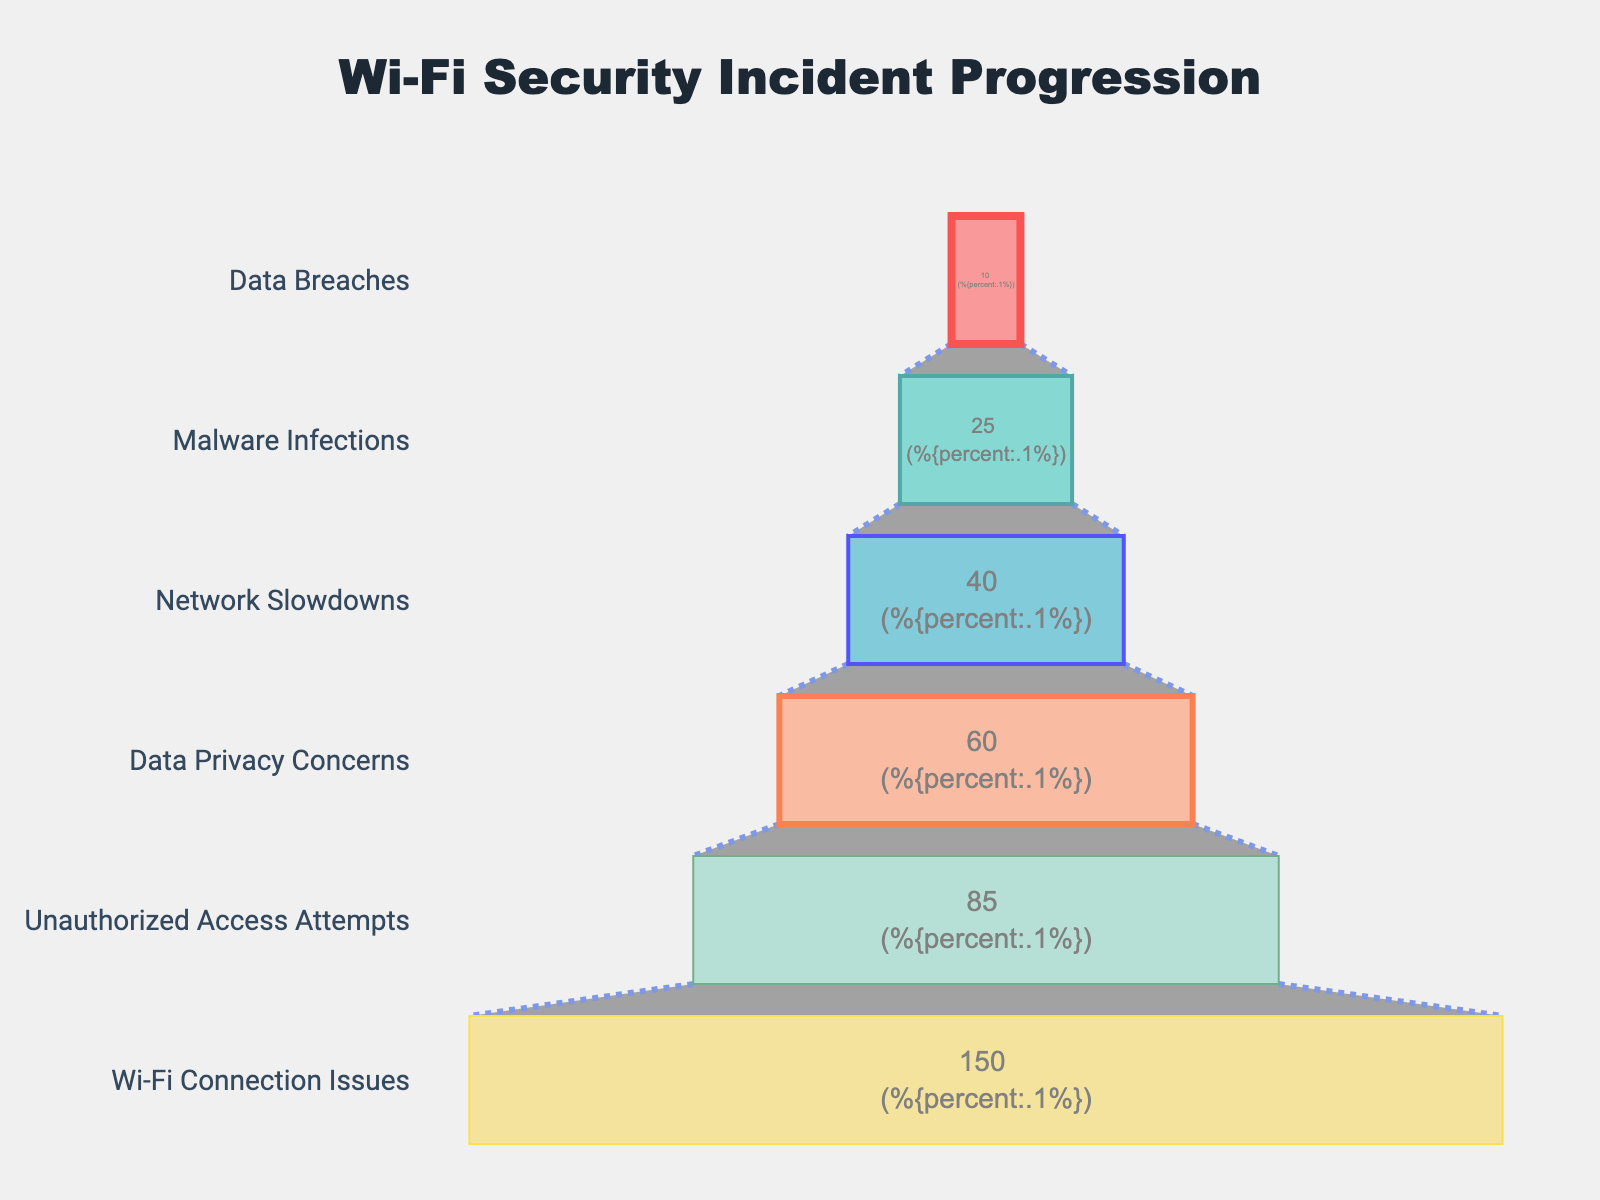What is the title of the Funnel Chart? The title of the Funnel Chart is located at the top of the figure and reads "Wi-Fi Security Incident Progression."
Answer: Wi-Fi Security Incident Progression How many stages are represented in the Funnel Chart? Each row in the chart represents a stage, so we count the number of rows to find the total number of stages. There are six stages in the chart.
Answer: six Which stage has the highest number of incidents? The stage with the highest number of incidents is the first one listed in the chart, which is "Wi-Fi Connection Issues" with 150 incidents.
Answer: Wi-Fi Connection Issues How many incidents are attributed to Malware Infections? We look for the stage labeled "Malware Infections" and see that it has 25 incidents.
Answer: 25 What percentage of initial incidents are Data Privacy Concerns? Initially, there are 150 incidents of Wi-Fi Connection Issues. Data Privacy Concerns have 60 incidents. The percentage is (60 / 150) * 100.
Answer: 40% How many more incidents are there for Wi-Fi Connection Issues compared to Network Slowdowns? Wi-Fi Connection Issues have 150 incidents, and Network Slowdowns have 40 incidents. The difference is 150 - 40.
Answer: 110 What is the combined number of incidents for Unauthorized Access Attempts and Data Breaches? Unauthorized Access Attempts have 85 incidents, and Data Breaches have 10 incidents. Their combined total is 85 + 10.
Answer: 95 Which stages have fewer incidents than Data Privacy Concerns? Data Privacy Concerns have 60 incidents. The stages "Network Slowdowns" (40 incidents), "Malware Infections" (25 incidents), and "Data Breaches" (10 incidents) all have fewer incidents.
Answer: Network Slowdowns, Malware Infections, Data Breaches What is the average number of incidents across all stages? Sum all the incidents (150 + 85 + 60 + 40 + 25 + 10) to get 370. Divide by the number of stages, which is 6. The average is 370 / 6.
Answer: approximately 61.67 What trend can be observed in the number of incidents as we move from minor to severe stages in the funnel? As we move from minor to severe stages, the number of incidents decreases. This trend demonstrates a reduction in the number of incidents at each consecutive stage of severity.
Answer: The number of incidents decreases 